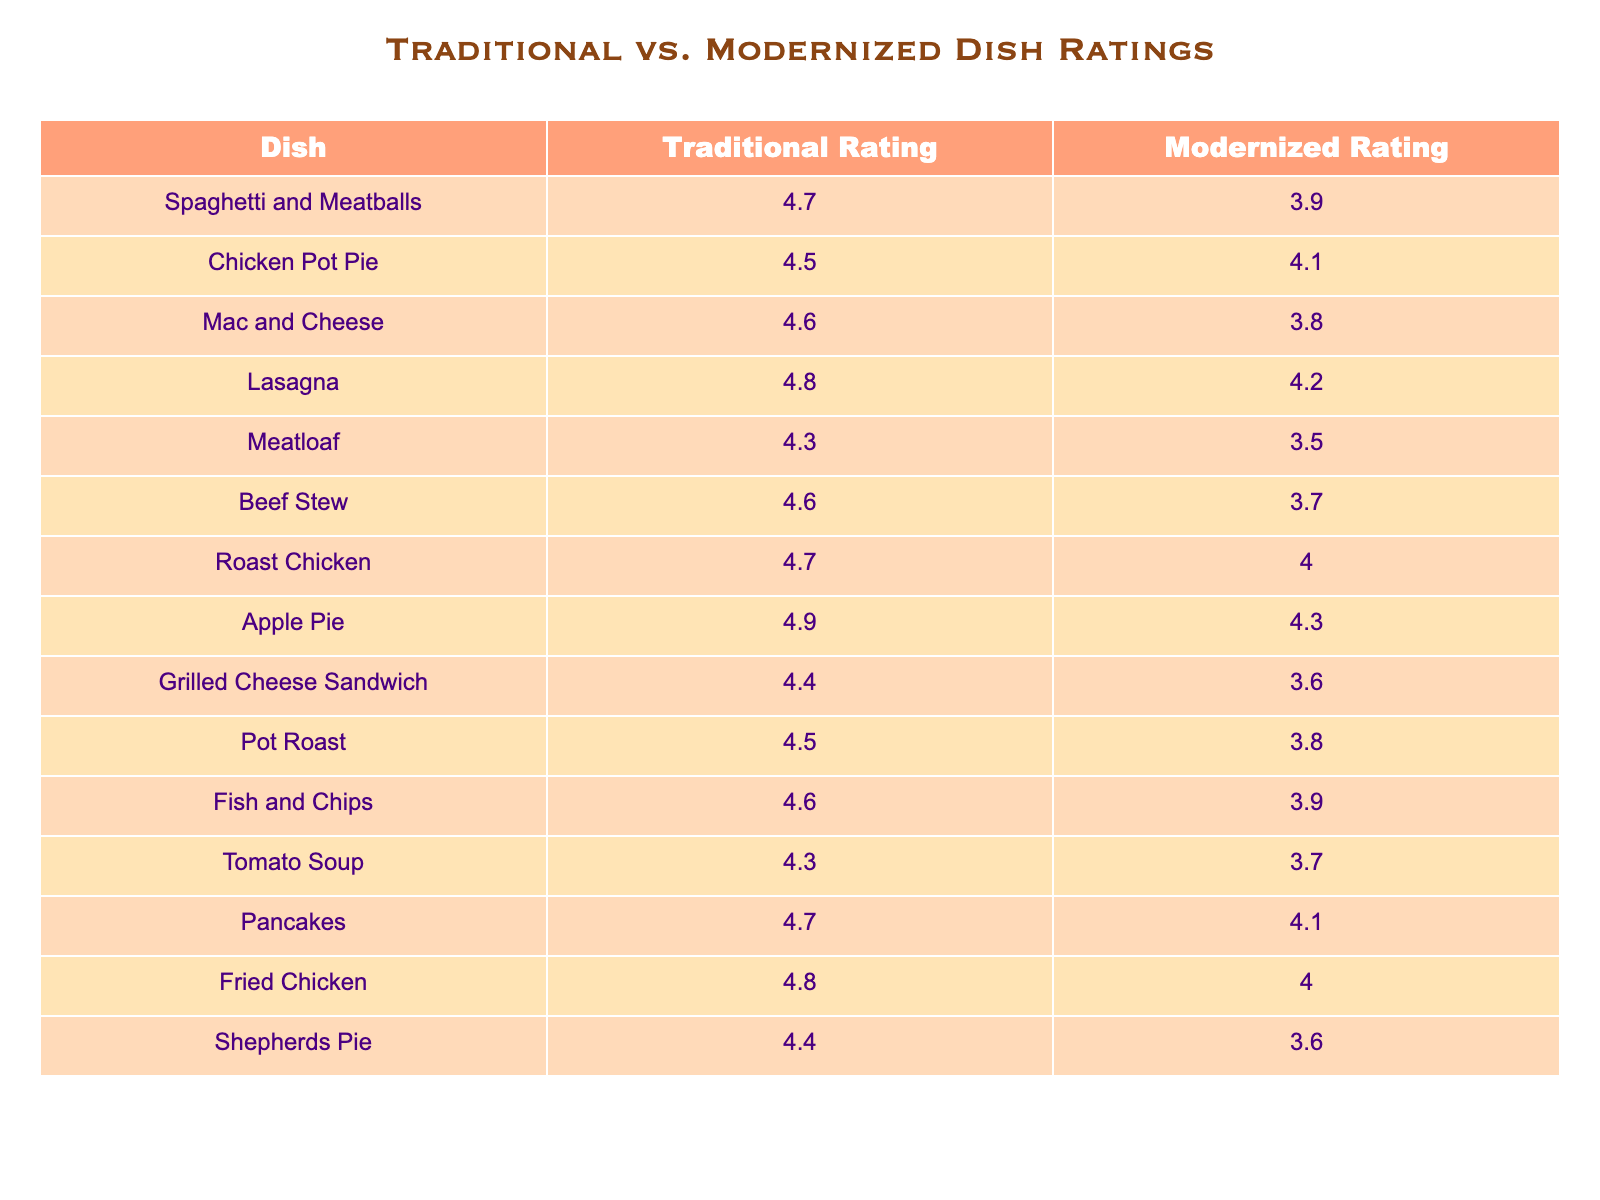What is the traditional rating for Chicken Pot Pie? The table indicates that the traditional rating for Chicken Pot Pie is listed under the 'Traditional Rating' column for that dish. The value is 4.5.
Answer: 4.5 What dish has the highest traditional rating? By comparing the traditional ratings of all the dishes, Apple Pie has the highest rating at 4.9.
Answer: Apple Pie Calculate the average traditional rating for all the dishes. The traditional ratings are: 4.7, 4.5, 4.6, 4.8, 4.3, 4.6, 4.7, 4.9, 4.4, 4.5, 4.6, 4.3, 4.7, 4.8, and 4.4. Summing these gives 66.3. There are 15 dishes, so the average is 66.3 / 15 = 4.42.
Answer: 4.42 Is the modernized rating for Mac and Cheese higher than that for Meatloaf? The modernized rating for Mac and Cheese is 3.8, while for Meatloaf it is 3.5. Since 3.8 is greater than 3.5, the statement is true.
Answer: Yes Which dish has the largest difference between traditional and modernized ratings? To find the largest difference, we calculate the difference for each dish: Spaghetti and Meatballs (4.7 - 3.9 = 0.8), Chicken Pot Pie (4.5 - 4.1 = 0.4), etc. The largest difference is for Spaghetti and Meatballs with 0.8.
Answer: Spaghetti and Meatballs What percentage of dishes have a traditional rating above 4.5? The dishes with traditional ratings above 4.5 are: Spaghetti and Meatballs, Chicken Pot Pie, Lasagna, Roast Chicken, Apple Pie, Fried Chicken. That is 6 out of 15 dishes. The percentage is (6/15)*100 = 40%.
Answer: 40% Compare the average modernized ratings to the average traditional ratings. The average traditional rating is 4.42 (from a previous calculation). The modernized ratings are: 3.9, 4.1, 3.8, 4.2, 3.5, 3.7, 4.0, 4.3, 3.6, 3.8, 3.9, 3.7, 4.1, 4.0, 3.6, summing these gives 56.4. Divided by 15 gives an average of 3.76 for modernized. Traditional average is higher at 4.42 compared to 3.76.
Answer: Traditional ratings are higher How many dishes have a modernized rating below 4.0? Looking through the modernized ratings, the dishes below 4.0 are Meatloaf (3.5), Grilled Cheese Sandwich (3.6), and Shepherds Pie (3.6). This counts for 3 dishes total.
Answer: 3 Is there a dish where the traditional rating is equal to the modernized rating? By comparing both columns, there isn’t any dish where the traditional rating matches the modernized rating; all values differ.
Answer: No 